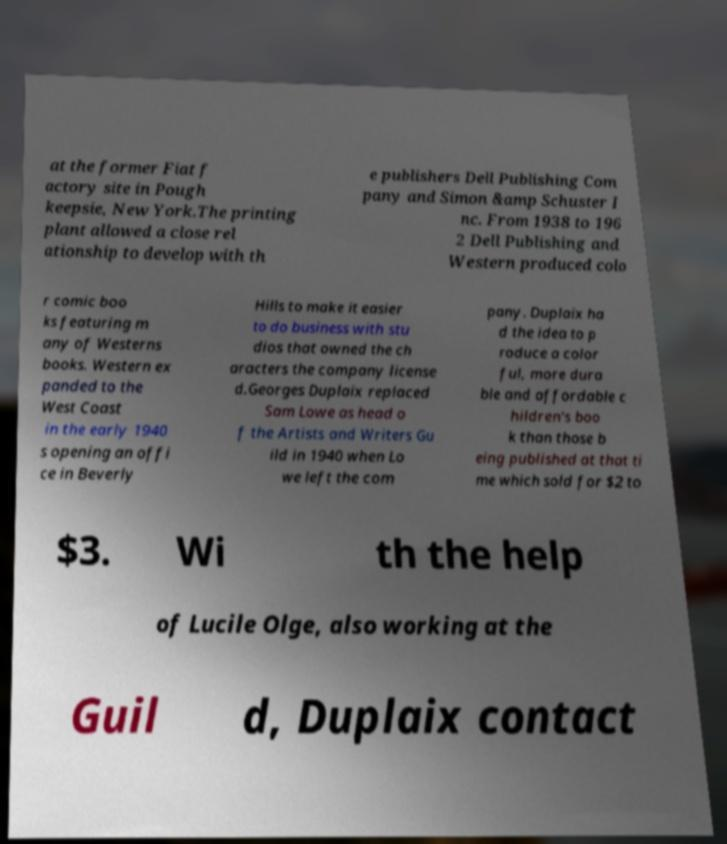Please read and relay the text visible in this image. What does it say? at the former Fiat f actory site in Pough keepsie, New York.The printing plant allowed a close rel ationship to develop with th e publishers Dell Publishing Com pany and Simon &amp Schuster I nc. From 1938 to 196 2 Dell Publishing and Western produced colo r comic boo ks featuring m any of Westerns books. Western ex panded to the West Coast in the early 1940 s opening an offi ce in Beverly Hills to make it easier to do business with stu dios that owned the ch aracters the company license d.Georges Duplaix replaced Sam Lowe as head o f the Artists and Writers Gu ild in 1940 when Lo we left the com pany. Duplaix ha d the idea to p roduce a color ful, more dura ble and affordable c hildren's boo k than those b eing published at that ti me which sold for $2 to $3. Wi th the help of Lucile Olge, also working at the Guil d, Duplaix contact 